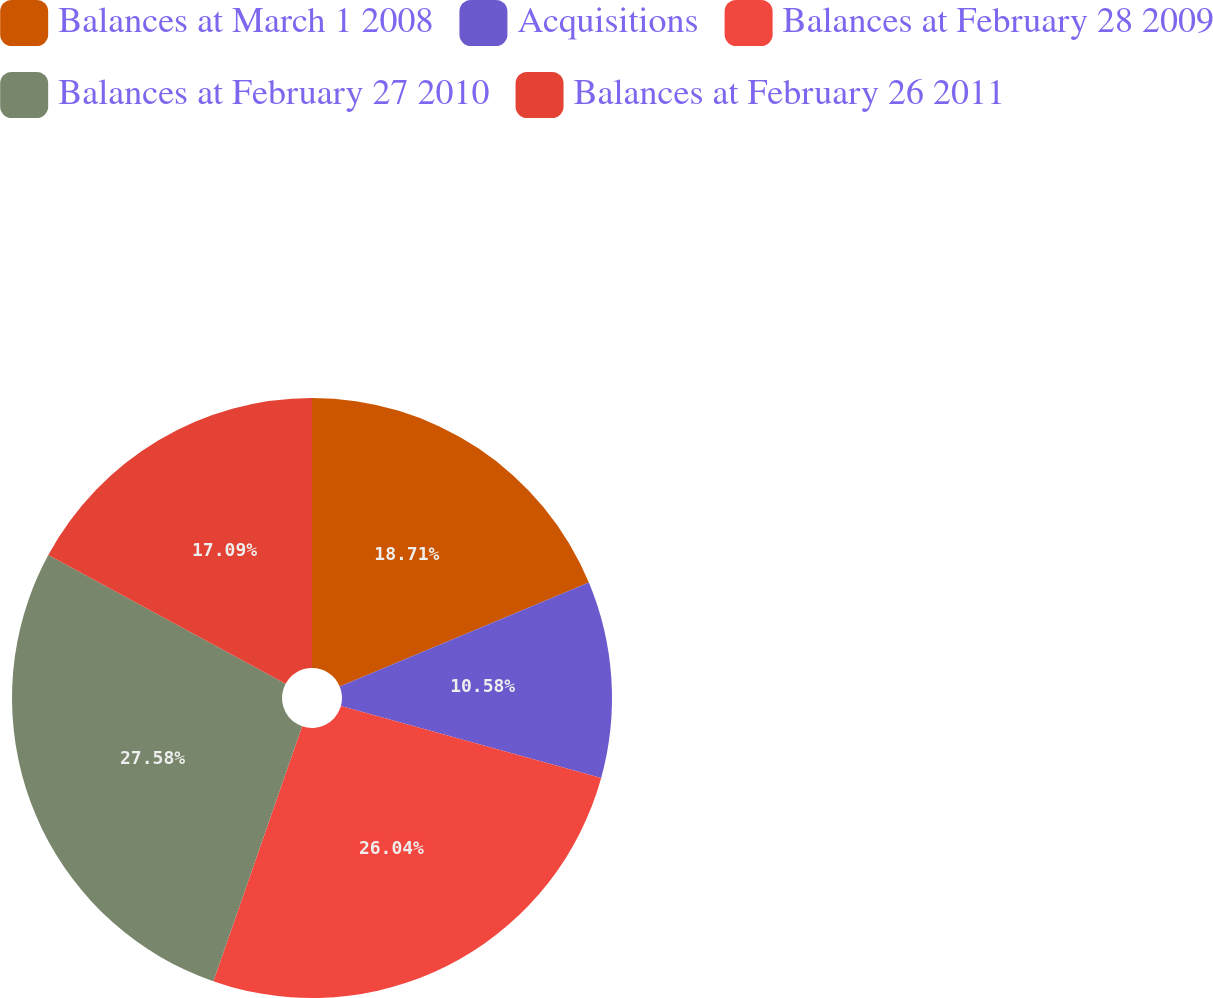Convert chart. <chart><loc_0><loc_0><loc_500><loc_500><pie_chart><fcel>Balances at March 1 2008<fcel>Acquisitions<fcel>Balances at February 28 2009<fcel>Balances at February 27 2010<fcel>Balances at February 26 2011<nl><fcel>18.71%<fcel>10.58%<fcel>26.04%<fcel>27.58%<fcel>17.09%<nl></chart> 